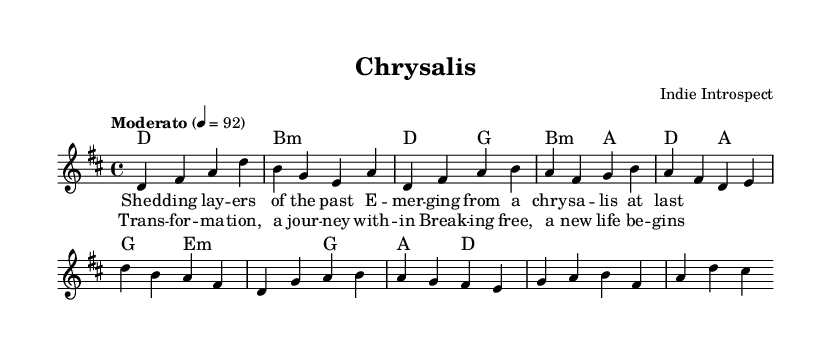What is the key signature of this music? The key signature is indicated at the beginning of the staff, which shows two sharps. This indicates that the key is D major.
Answer: D major What is the time signature of this music? The time signature is shown at the beginning of the score, indicated as 4/4, meaning there are four beats in a measure.
Answer: 4/4 What is the tempo marking for this piece? The tempo marking is indicated in words, showing "Moderato" and the metronome marking of quarter note equals ninety-two, which suggests a moderate pace.
Answer: Moderato How many measures are in the introduction section? The introduction comprises a single line with four measures that can be counted.
Answer: 4 What is the first lyric for the verse? The first lyric of the verse is found at the beginning of the lyric section, which is "Shed".
Answer: Shed In which section does the phrase "a new life begins" appear? This phrase appears in the chorus section, as can be seen under the appropriate lyrics below the melody staff, highlighting the distinctive part of the song.
Answer: Chorus What components are included in the score? The score includes different components such as melody, harmonies, and lyrics, as indicated in the score structure. Specifically, there are two harmonies and two lyric staves for the lead voice.
Answer: Melody, harmonies, lyrics 